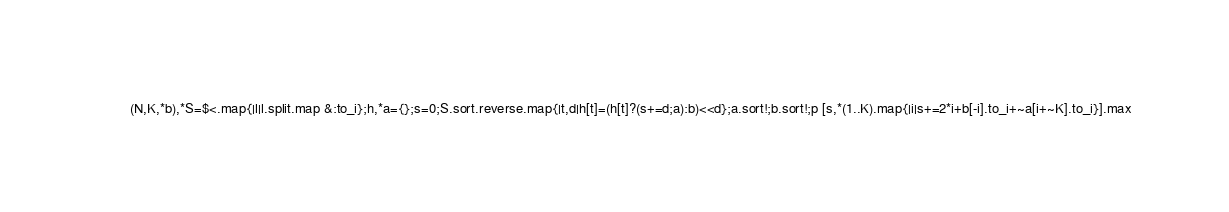Convert code to text. <code><loc_0><loc_0><loc_500><loc_500><_Ruby_>(N,K,*b),*S=$<.map{|l|l.split.map &:to_i};h,*a={};s=0;S.sort.reverse.map{|t,d|h[t]=(h[t]?(s+=d;a):b)<<d};a.sort!;b.sort!;p [s,*(1..K).map{|i|s+=2*i+b[-i].to_i+~a[i+~K].to_i}].max</code> 